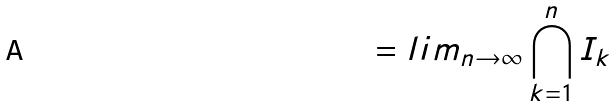Convert formula to latex. <formula><loc_0><loc_0><loc_500><loc_500>= l i m _ { n \rightarrow \infty } \bigcap _ { k = 1 } ^ { n } I _ { k }</formula> 